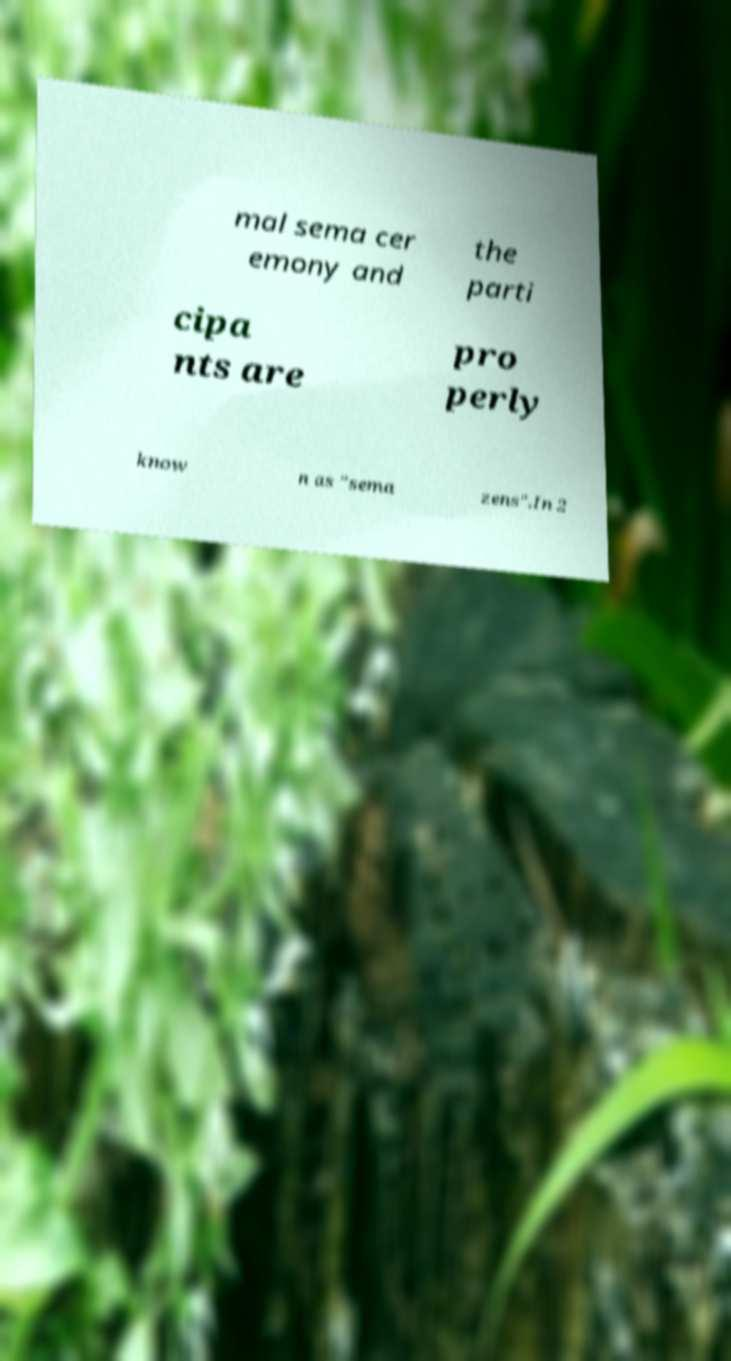For documentation purposes, I need the text within this image transcribed. Could you provide that? mal sema cer emony and the parti cipa nts are pro perly know n as "sema zens".In 2 